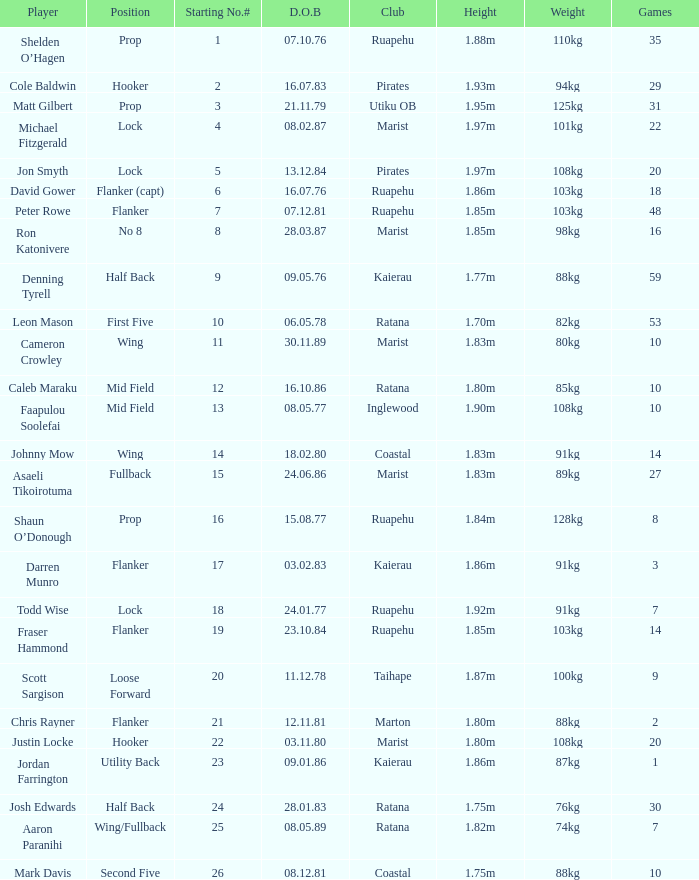What placement does the competitor todd wise occupy in? Lock. 